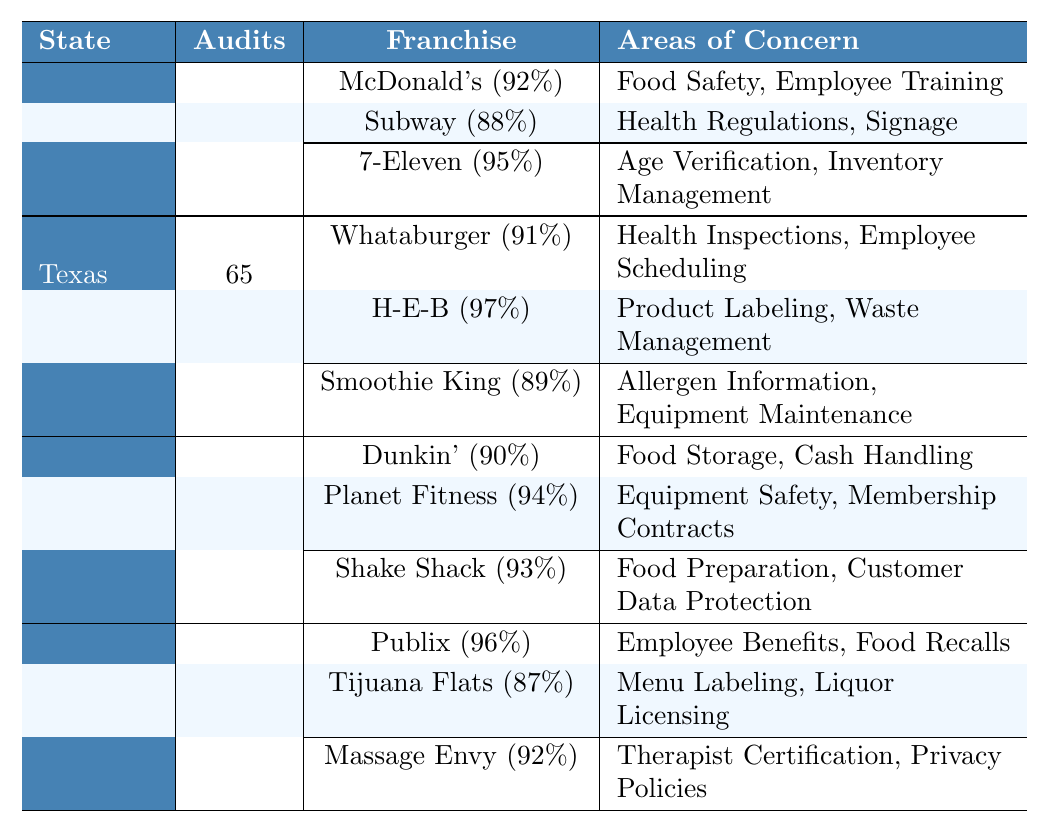What is the compliance score of 7-Eleven in California? The table shows the compliance score of 7-Eleven listed under California as 95.
Answer: 95 What areas of concern does Subway have in California? According to the table, the areas of concern for Subway are "Health Regulations" and "Signage."
Answer: Health Regulations, Signage Which franchise has the highest compliance score in Texas? By examining the Texas section of the table, H-E-B has the highest compliance score listed as 97.
Answer: H-E-B How many audits were conducted in New York? The table indicates that a total of 93 audits were conducted in New York.
Answer: 93 What is the average compliance score of franchises in Florida? The compliance scores for franchises in Florida are 96 (Publix), 87 (Tijuana Flats), and 92 (Massage Envy). The sum is (96 + 87 + 92) = 275, and the average is 275/3 = 91.67.
Answer: 91.67 Did any franchise in California receive a compliance score below 90? The table shows that Subway scores 88, which is below 90.
Answer: Yes In which state was the most number of audits conducted? By looking at the number of audits, California had 87 audits, New York had 93, Texas had 65, and Florida had 72; thus, New York had the most audits.
Answer: New York What is the total number of audits conducted across all states? The audits conducted are 87 (California) + 65 (Texas) + 93 (New York) + 72 (Florida) = 317.
Answer: 317 How many areas of concern does Shake Shack have in New York? Shake Shack has two areas of concern listed: "Food Preparation" and "Customer Data Protection."
Answer: 2 Which franchise has the lowest compliance score in Texas, and what is that score? The lowest compliance score in Texas is for Smoothie King with a score of 89.
Answer: Smoothie King, 89 What percentage of franchises in California has a compliance score of 90 or higher? California has 3 franchises; McDonald's (92), Subway (88), and 7-Eleven (95). Only 2 franchises, McDonald's and 7-Eleven, have scores of 90 or higher. The percentage is (2/3)*100 = 66.67%.
Answer: 66.67% Which franchise in Florida has a compliance score closest to the average score of all franchises in that state? The average score for Florida is 91.67, and the closest score is 92 (Massage Envy).
Answer: Massage Envy How many franchises in New York scored above 90? The franchises in New York are Dunkin' (90), Planet Fitness (94), and Shake Shack (93). Planet Fitness and Shake Shack scored above 90. Thus, there are 2 franchises above that threshold.
Answer: 2 